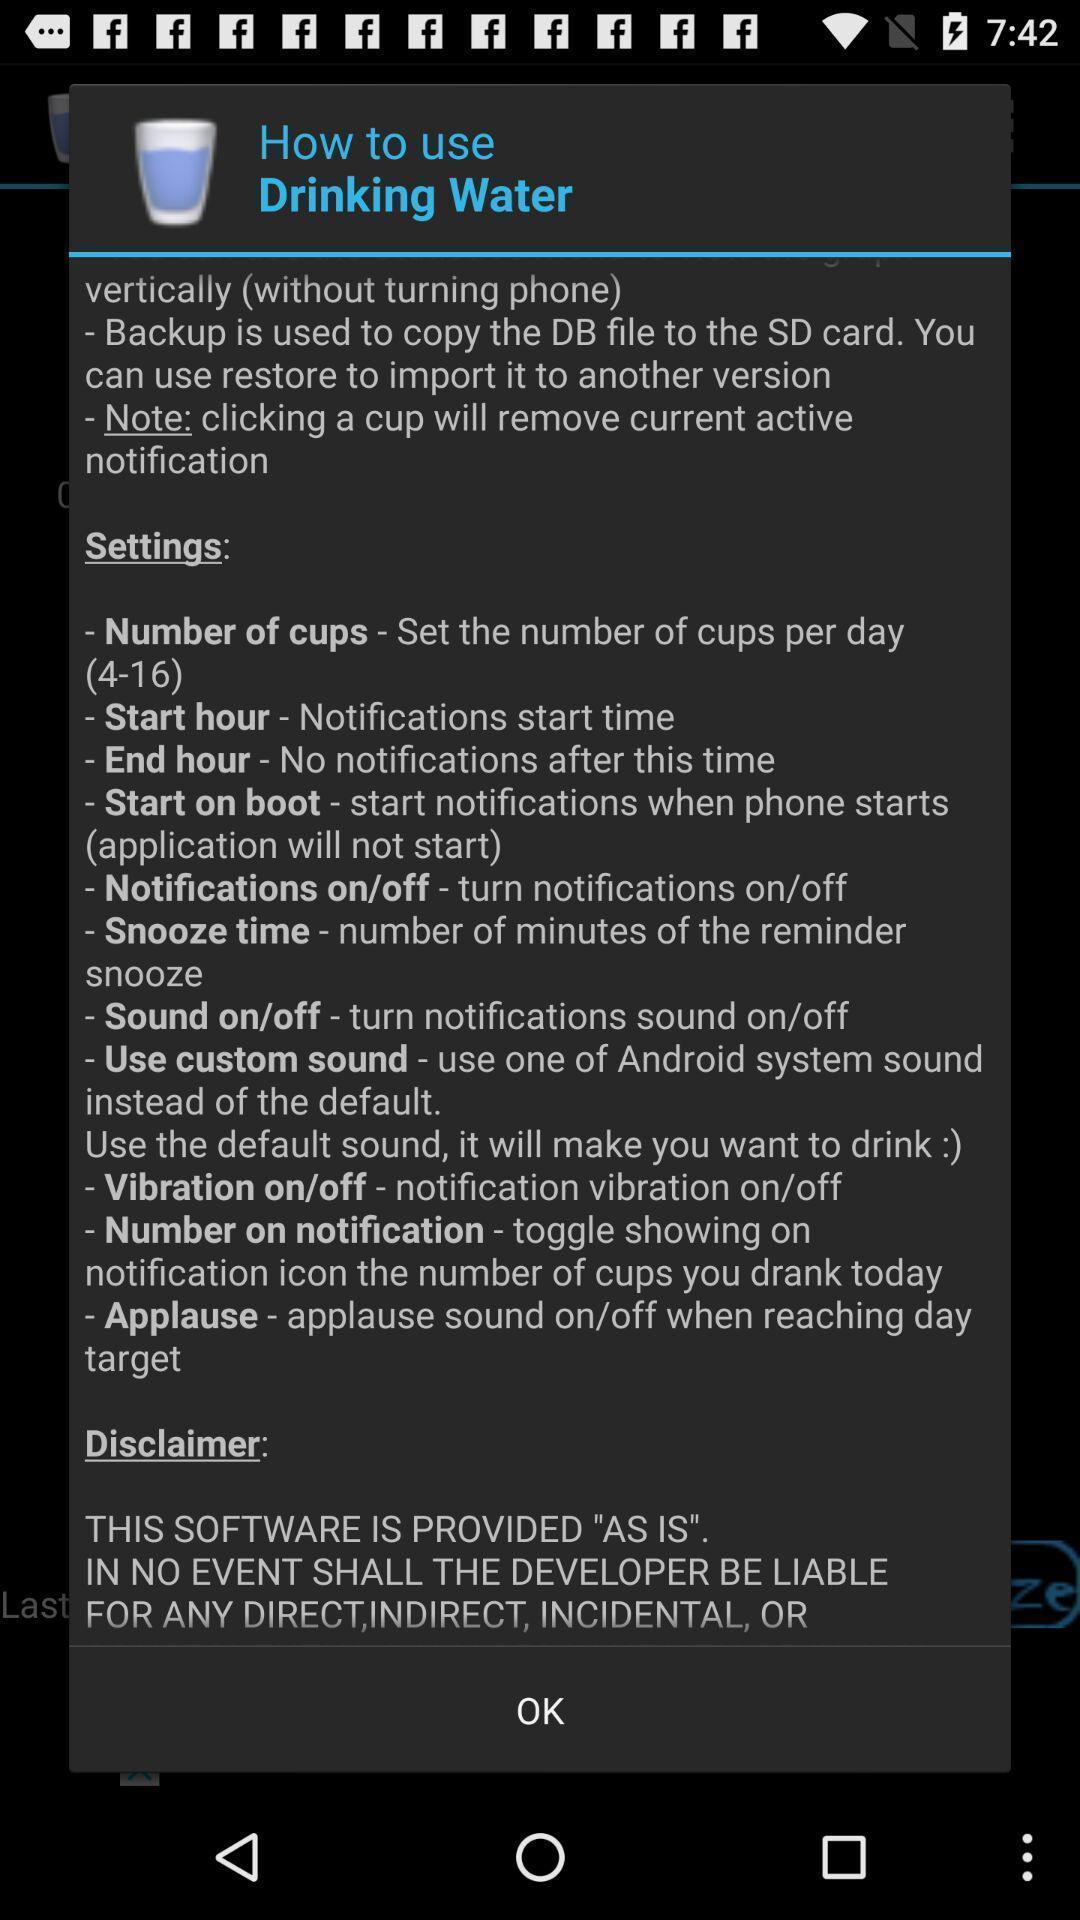Please provide a description for this image. Pop-up showing usage of drinking water. 